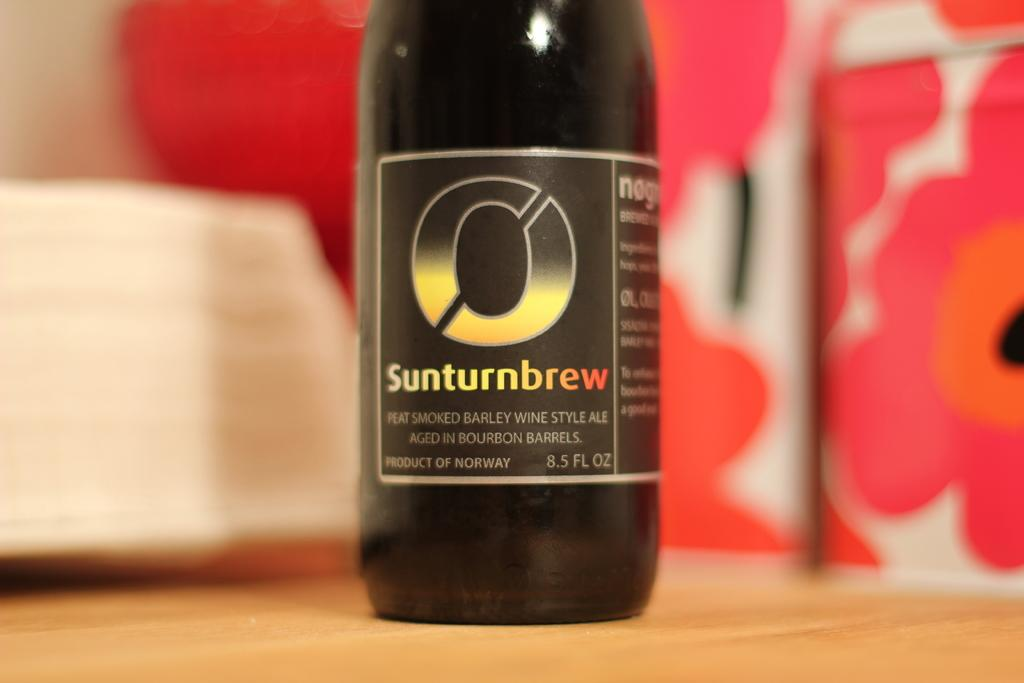<image>
Summarize the visual content of the image. A bottle of Sunturnbrew that was aged in bourbon barrels 